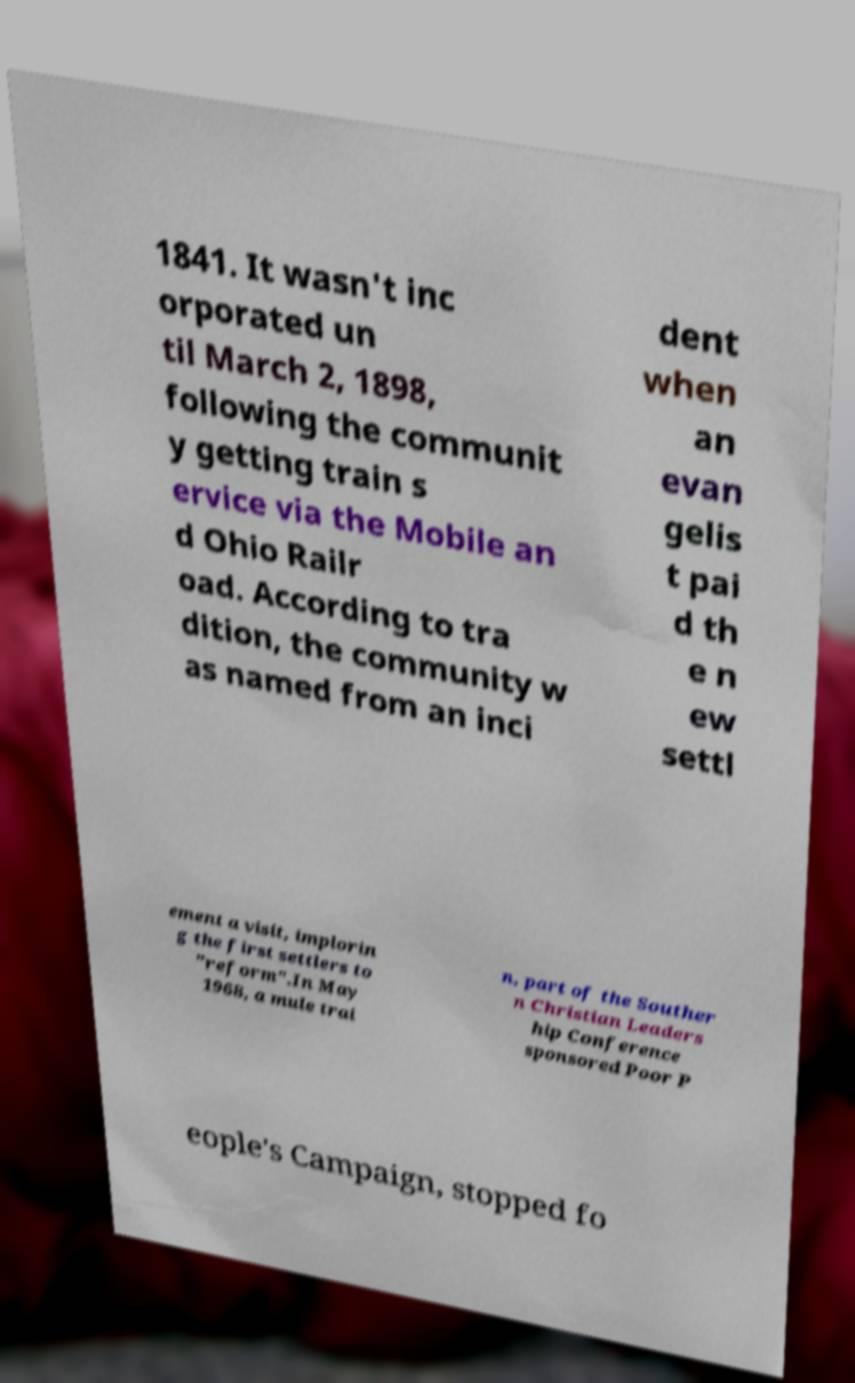Can you read and provide the text displayed in the image?This photo seems to have some interesting text. Can you extract and type it out for me? 1841. It wasn't inc orporated un til March 2, 1898, following the communit y getting train s ervice via the Mobile an d Ohio Railr oad. According to tra dition, the community w as named from an inci dent when an evan gelis t pai d th e n ew settl ement a visit, implorin g the first settlers to "reform".In May 1968, a mule trai n, part of the Souther n Christian Leaders hip Conference sponsored Poor P eople's Campaign, stopped fo 